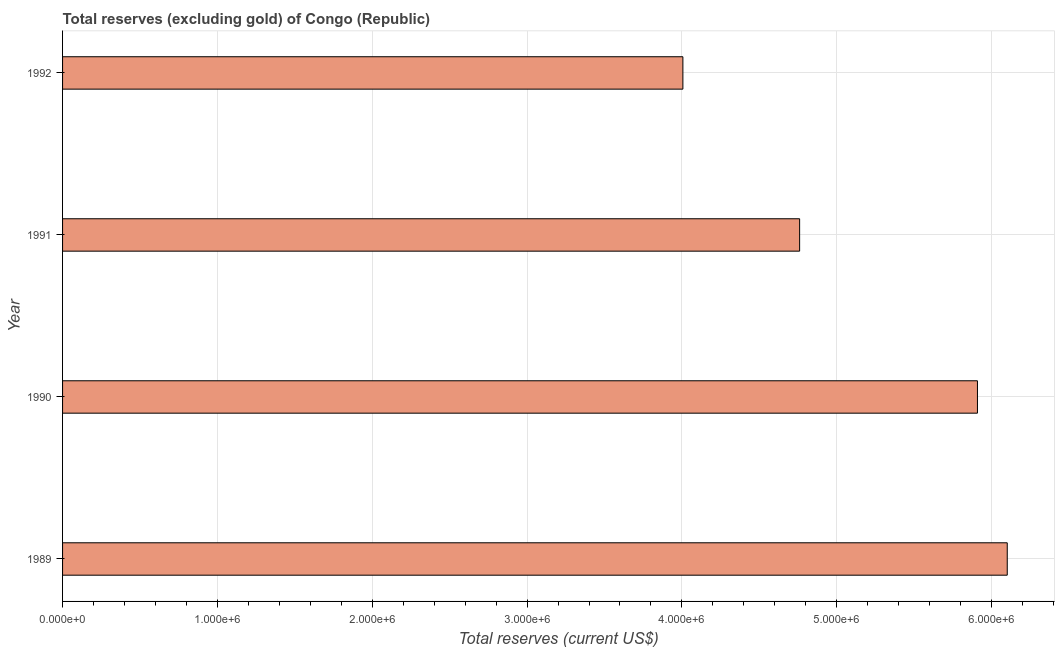Does the graph contain grids?
Offer a very short reply. Yes. What is the title of the graph?
Your response must be concise. Total reserves (excluding gold) of Congo (Republic). What is the label or title of the X-axis?
Your answer should be compact. Total reserves (current US$). What is the label or title of the Y-axis?
Provide a succinct answer. Year. What is the total reserves (excluding gold) in 1992?
Keep it short and to the point. 4.01e+06. Across all years, what is the maximum total reserves (excluding gold)?
Keep it short and to the point. 6.10e+06. Across all years, what is the minimum total reserves (excluding gold)?
Keep it short and to the point. 4.01e+06. In which year was the total reserves (excluding gold) maximum?
Provide a short and direct response. 1989. What is the sum of the total reserves (excluding gold)?
Provide a succinct answer. 2.08e+07. What is the difference between the total reserves (excluding gold) in 1989 and 1991?
Make the answer very short. 1.34e+06. What is the average total reserves (excluding gold) per year?
Offer a very short reply. 5.19e+06. What is the median total reserves (excluding gold)?
Offer a terse response. 5.33e+06. Do a majority of the years between 1990 and 1992 (inclusive) have total reserves (excluding gold) greater than 200000 US$?
Give a very brief answer. Yes. What is the ratio of the total reserves (excluding gold) in 1989 to that in 1991?
Your answer should be compact. 1.28. Is the total reserves (excluding gold) in 1990 less than that in 1991?
Give a very brief answer. No. Is the difference between the total reserves (excluding gold) in 1990 and 1992 greater than the difference between any two years?
Make the answer very short. No. What is the difference between the highest and the second highest total reserves (excluding gold)?
Offer a terse response. 1.92e+05. Is the sum of the total reserves (excluding gold) in 1991 and 1992 greater than the maximum total reserves (excluding gold) across all years?
Offer a very short reply. Yes. What is the difference between the highest and the lowest total reserves (excluding gold)?
Keep it short and to the point. 2.09e+06. In how many years, is the total reserves (excluding gold) greater than the average total reserves (excluding gold) taken over all years?
Provide a succinct answer. 2. How many bars are there?
Your answer should be very brief. 4. How many years are there in the graph?
Offer a very short reply. 4. What is the difference between two consecutive major ticks on the X-axis?
Offer a very short reply. 1.00e+06. Are the values on the major ticks of X-axis written in scientific E-notation?
Make the answer very short. Yes. What is the Total reserves (current US$) of 1989?
Your answer should be compact. 6.10e+06. What is the Total reserves (current US$) in 1990?
Make the answer very short. 5.91e+06. What is the Total reserves (current US$) in 1991?
Make the answer very short. 4.76e+06. What is the Total reserves (current US$) of 1992?
Your answer should be compact. 4.01e+06. What is the difference between the Total reserves (current US$) in 1989 and 1990?
Give a very brief answer. 1.92e+05. What is the difference between the Total reserves (current US$) in 1989 and 1991?
Give a very brief answer. 1.34e+06. What is the difference between the Total reserves (current US$) in 1989 and 1992?
Keep it short and to the point. 2.09e+06. What is the difference between the Total reserves (current US$) in 1990 and 1991?
Provide a succinct answer. 1.15e+06. What is the difference between the Total reserves (current US$) in 1990 and 1992?
Offer a terse response. 1.90e+06. What is the difference between the Total reserves (current US$) in 1991 and 1992?
Ensure brevity in your answer.  7.54e+05. What is the ratio of the Total reserves (current US$) in 1989 to that in 1990?
Your response must be concise. 1.03. What is the ratio of the Total reserves (current US$) in 1989 to that in 1991?
Provide a succinct answer. 1.28. What is the ratio of the Total reserves (current US$) in 1989 to that in 1992?
Keep it short and to the point. 1.52. What is the ratio of the Total reserves (current US$) in 1990 to that in 1991?
Your answer should be very brief. 1.24. What is the ratio of the Total reserves (current US$) in 1990 to that in 1992?
Your answer should be compact. 1.48. What is the ratio of the Total reserves (current US$) in 1991 to that in 1992?
Your answer should be very brief. 1.19. 